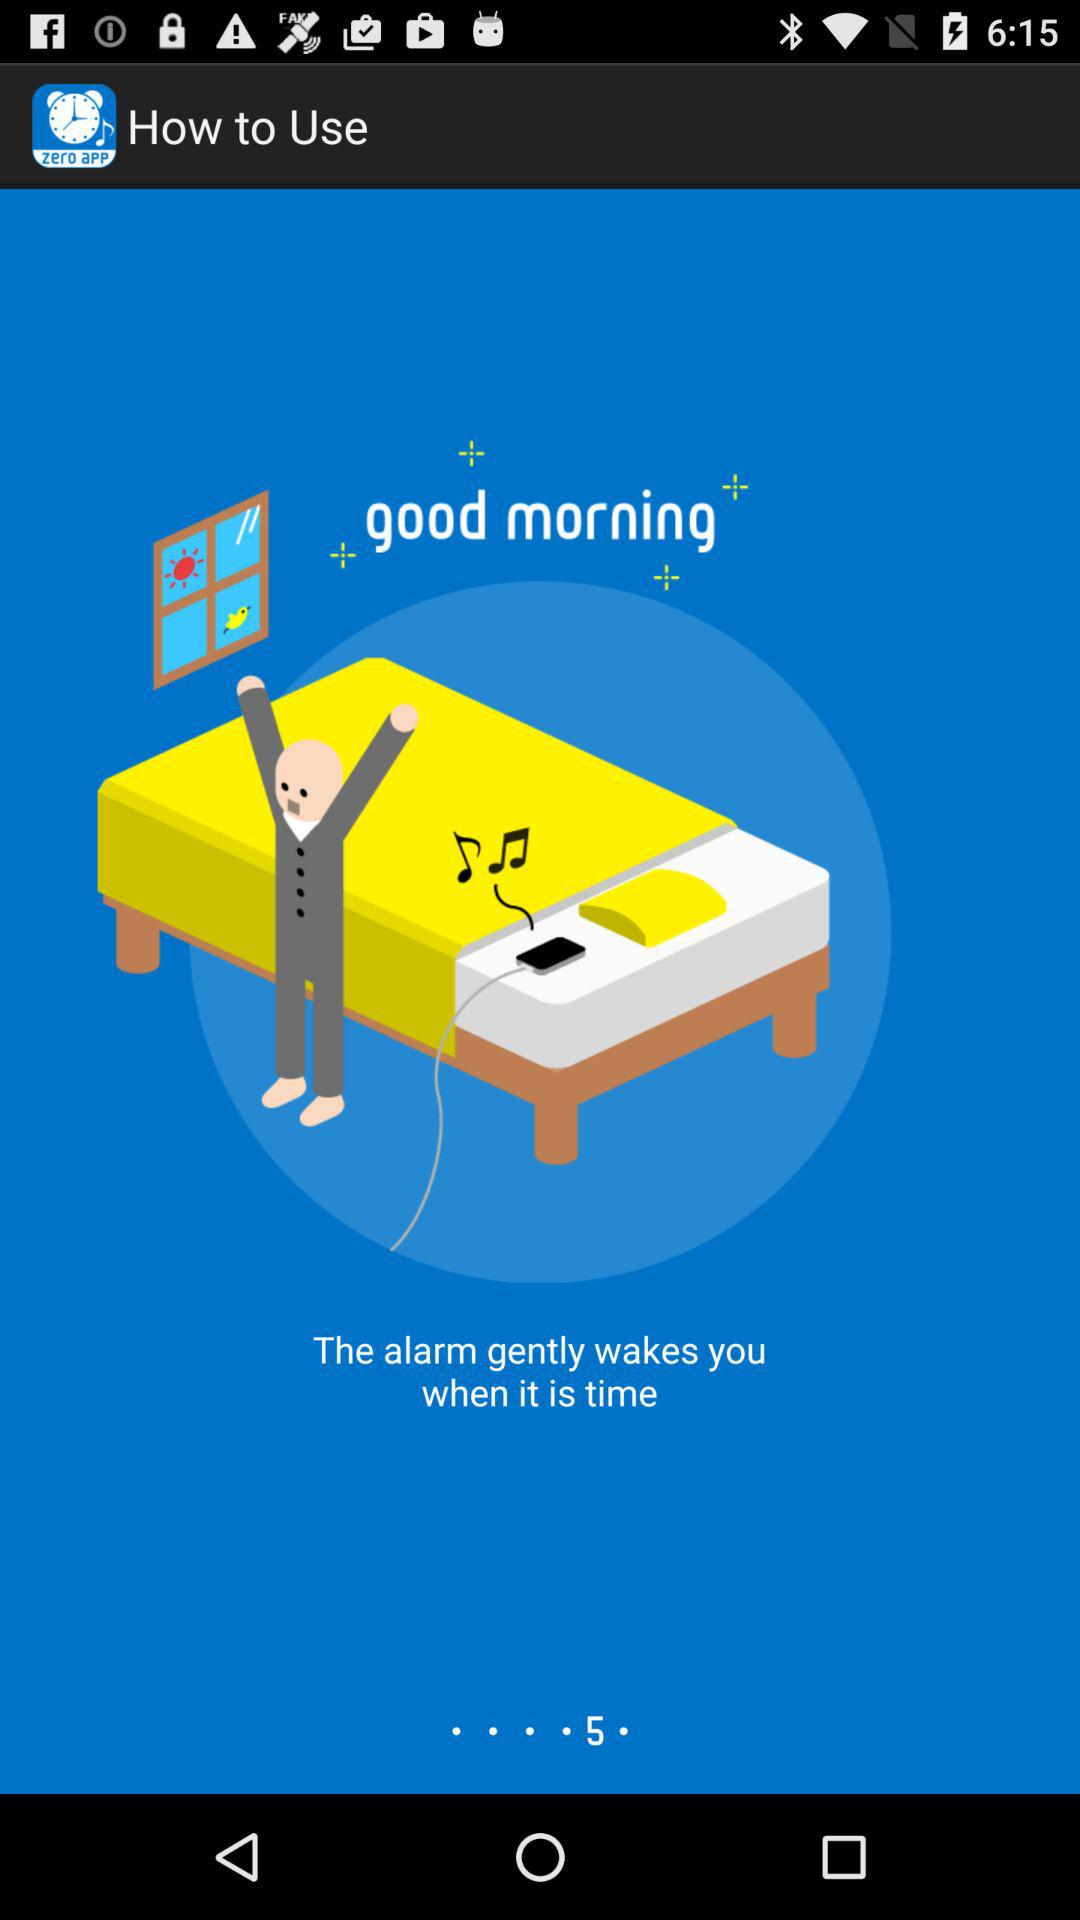What is the name of the application? The name of the application is "Sleep Cycle Clock - Alarm Clock Alarm". 